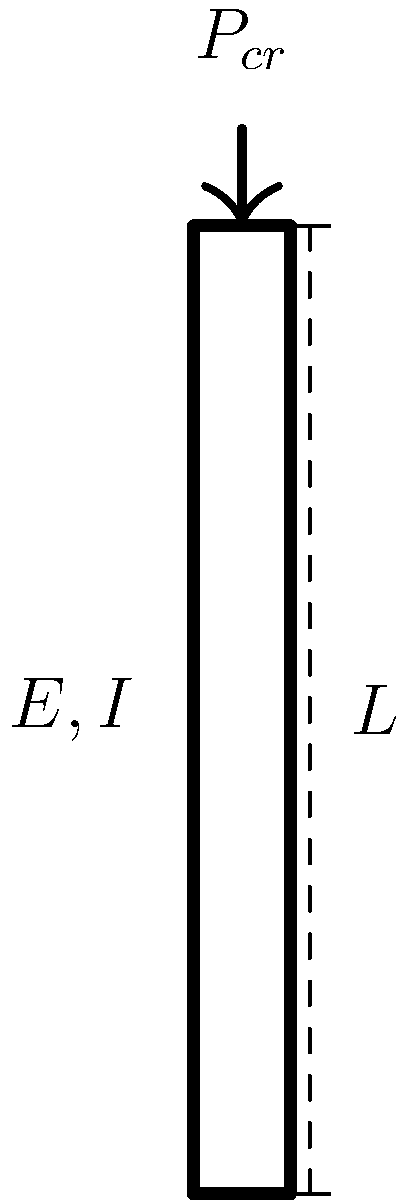During a quick break between patient rounds, you recall a civil engineering problem from your undergraduate studies. Consider a steel column with length $L = 4$ m, Young's modulus $E = 200$ GPa, and moment of inertia $I = 1.5 \times 10^{-5}$ m⁴. The column has fixed-free end conditions (fixed at the bottom, free at the top). What is the critical buckling load $P_{cr}$ for this column using Euler's formula? To solve this problem, we'll use Euler's formula for the critical buckling load:

$$P_{cr} = \frac{\pi^2 EI}{(KL)^2}$$

Where:
- $P_{cr}$ is the critical buckling load
- $E$ is Young's modulus
- $I$ is the moment of inertia
- $L$ is the length of the column
- $K$ is the effective length factor

Steps:
1) For a fixed-free column, $K = 2$.

2) We have:
   $E = 200 \times 10^9$ Pa
   $I = 1.5 \times 10^{-5}$ m⁴
   $L = 4$ m
   $K = 2$

3) Substituting these values into Euler's formula:

   $$P_{cr} = \frac{\pi^2 (200 \times 10^9)(1.5 \times 10^{-5})}{(2 \times 4)^2}$$

4) Simplify:
   $$P_{cr} = \frac{\pi^2 (3 \times 10^6)}{64} = 146,608.4 \text{ N}$$

5) Round to three significant figures:
   $$P_{cr} \approx 147 \text{ kN}$$
Answer: 147 kN 